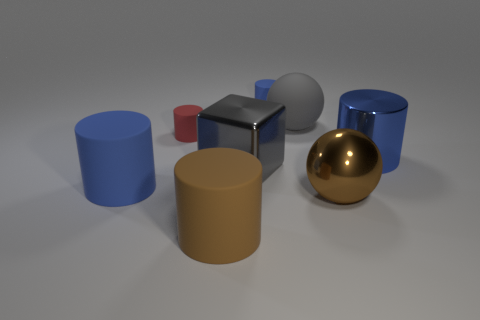Subtract all blue blocks. How many blue cylinders are left? 3 Subtract all red cylinders. How many cylinders are left? 4 Subtract all purple cylinders. Subtract all purple balls. How many cylinders are left? 5 Add 2 large metallic balls. How many objects exist? 10 Subtract all spheres. How many objects are left? 6 Add 3 blocks. How many blocks are left? 4 Add 1 brown matte cylinders. How many brown matte cylinders exist? 2 Subtract 0 brown blocks. How many objects are left? 8 Subtract all big gray objects. Subtract all big blue objects. How many objects are left? 4 